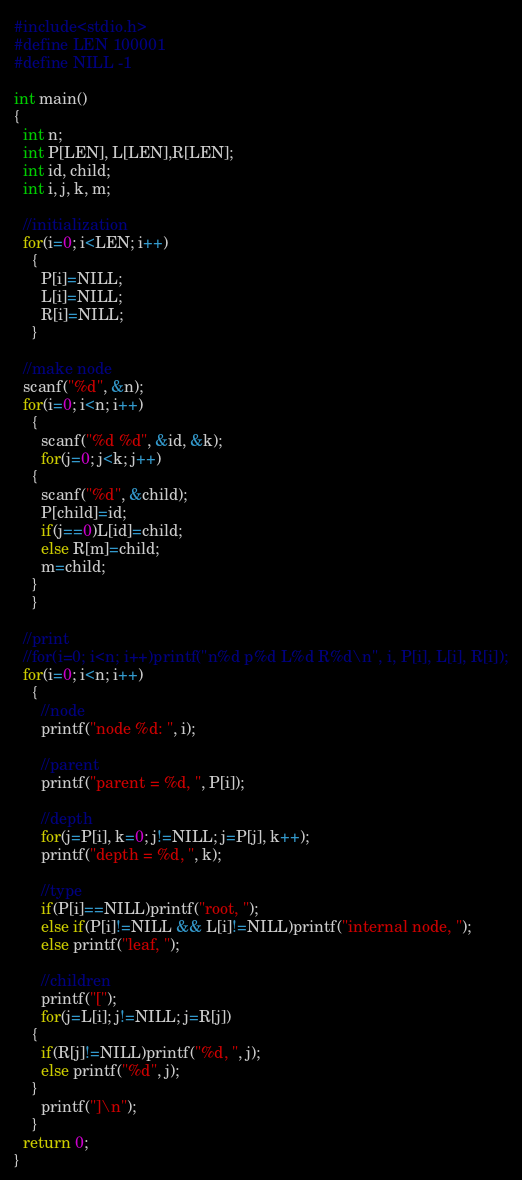Convert code to text. <code><loc_0><loc_0><loc_500><loc_500><_C_>#include<stdio.h>
#define LEN 100001
#define NILL -1

int main()
{
  int n;
  int P[LEN], L[LEN],R[LEN];
  int id, child;
  int i, j, k, m;  

  //initialization
  for(i=0; i<LEN; i++)
    {
      P[i]=NILL;
      L[i]=NILL;
      R[i]=NILL;
    }

  //make node
  scanf("%d", &n);
  for(i=0; i<n; i++)
    {
      scanf("%d %d", &id, &k);
      for(j=0; j<k; j++)
	{
	  scanf("%d", &child);
	  P[child]=id;
	  if(j==0)L[id]=child;
	  else R[m]=child;
	  m=child;
	}
    }

  //print
  //for(i=0; i<n; i++)printf("n%d p%d L%d R%d\n", i, P[i], L[i], R[i]);
  for(i=0; i<n; i++)
    {
      //node
      printf("node %d: ", i);

      //parent
      printf("parent = %d, ", P[i]);

      //depth
      for(j=P[i], k=0; j!=NILL; j=P[j], k++);
      printf("depth = %d, ", k);

      //type
      if(P[i]==NILL)printf("root, ");
      else if(P[i]!=NILL && L[i]!=NILL)printf("internal node, ");
      else printf("leaf, ");

      //children
      printf("[");
      for(j=L[i]; j!=NILL; j=R[j])
	{
	  if(R[j]!=NILL)printf("%d, ", j);
	  else printf("%d", j);
	}
      printf("]\n");
    }
  return 0;
}</code> 